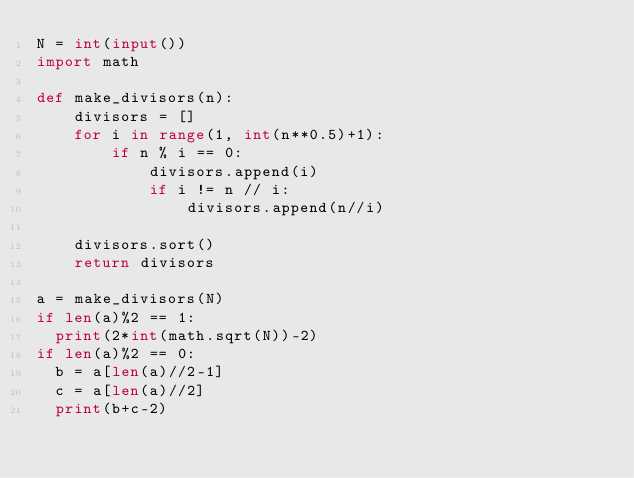<code> <loc_0><loc_0><loc_500><loc_500><_Python_>N = int(input())
import math

def make_divisors(n):
    divisors = []
    for i in range(1, int(n**0.5)+1):
        if n % i == 0:
            divisors.append(i)
            if i != n // i:
                divisors.append(n//i)

    divisors.sort()
    return divisors

a = make_divisors(N)
if len(a)%2 == 1:
  print(2*int(math.sqrt(N))-2)
if len(a)%2 == 0:
  b = a[len(a)//2-1]
  c = a[len(a)//2]
  print(b+c-2)</code> 